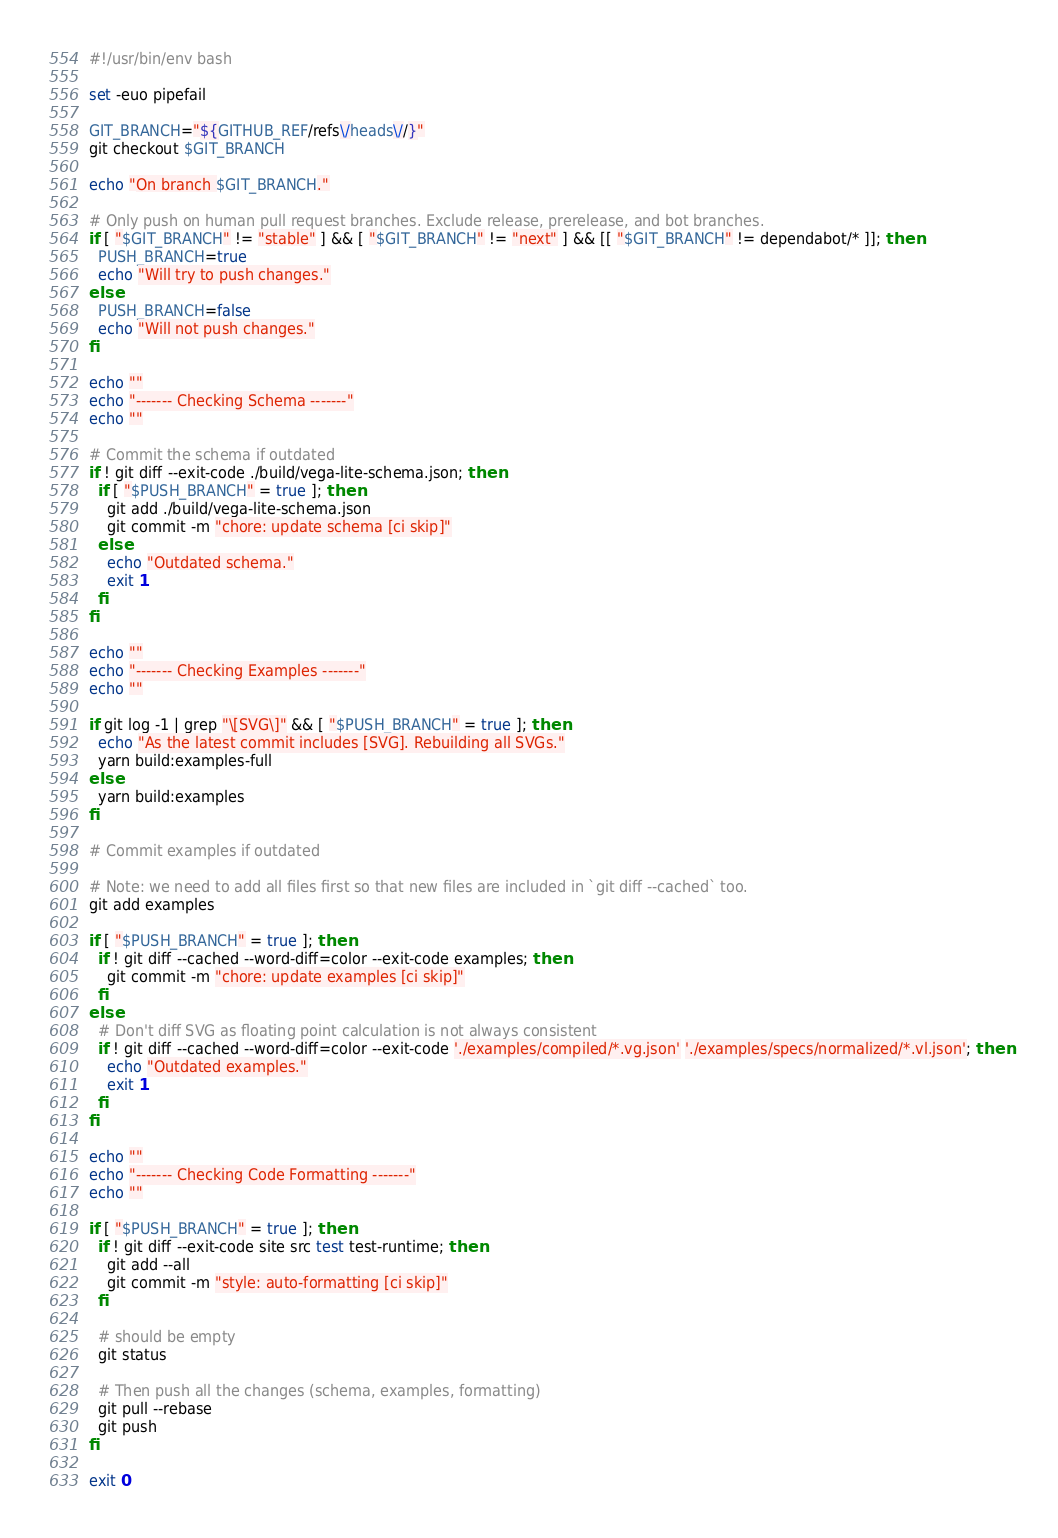Convert code to text. <code><loc_0><loc_0><loc_500><loc_500><_Bash_>#!/usr/bin/env bash

set -euo pipefail

GIT_BRANCH="${GITHUB_REF/refs\/heads\//}"
git checkout $GIT_BRANCH

echo "On branch $GIT_BRANCH."

# Only push on human pull request branches. Exclude release, prerelease, and bot branches.
if [ "$GIT_BRANCH" != "stable" ] && [ "$GIT_BRANCH" != "next" ] && [[ "$GIT_BRANCH" != dependabot/* ]]; then
  PUSH_BRANCH=true
  echo "Will try to push changes."
else
  PUSH_BRANCH=false
  echo "Will not push changes."
fi

echo ""
echo "------- Checking Schema -------"
echo ""

# Commit the schema if outdated
if ! git diff --exit-code ./build/vega-lite-schema.json; then
  if [ "$PUSH_BRANCH" = true ]; then
    git add ./build/vega-lite-schema.json
    git commit -m "chore: update schema [ci skip]"
  else
    echo "Outdated schema."
    exit 1
  fi
fi

echo ""
echo "------- Checking Examples -------"
echo ""

if git log -1 | grep "\[SVG\]" && [ "$PUSH_BRANCH" = true ]; then
  echo "As the latest commit includes [SVG]. Rebuilding all SVGs."
  yarn build:examples-full
else
  yarn build:examples
fi

# Commit examples if outdated

# Note: we need to add all files first so that new files are included in `git diff --cached` too.
git add examples

if [ "$PUSH_BRANCH" = true ]; then
  if ! git diff --cached --word-diff=color --exit-code examples; then
    git commit -m "chore: update examples [ci skip]"
  fi
else
  # Don't diff SVG as floating point calculation is not always consistent
  if ! git diff --cached --word-diff=color --exit-code './examples/compiled/*.vg.json' './examples/specs/normalized/*.vl.json'; then
    echo "Outdated examples."
    exit 1
  fi
fi

echo ""
echo "------- Checking Code Formatting -------"
echo ""

if [ "$PUSH_BRANCH" = true ]; then
  if ! git diff --exit-code site src test test-runtime; then
    git add --all
    git commit -m "style: auto-formatting [ci skip]"
  fi

  # should be empty
  git status

  # Then push all the changes (schema, examples, formatting)
  git pull --rebase
  git push
fi

exit 0
</code> 